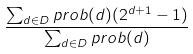Convert formula to latex. <formula><loc_0><loc_0><loc_500><loc_500>\frac { \sum _ { d \in { D } } p r o b ( d ) ( 2 ^ { d + 1 } - 1 ) } { \sum _ { d \in { D } } p r o b ( d ) }</formula> 